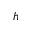Convert formula to latex. <formula><loc_0><loc_0><loc_500><loc_500>h</formula> 